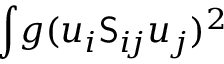<formula> <loc_0><loc_0><loc_500><loc_500>\int \, g ( u _ { i } S _ { i \, j } u _ { j } ) ^ { 2 }</formula> 